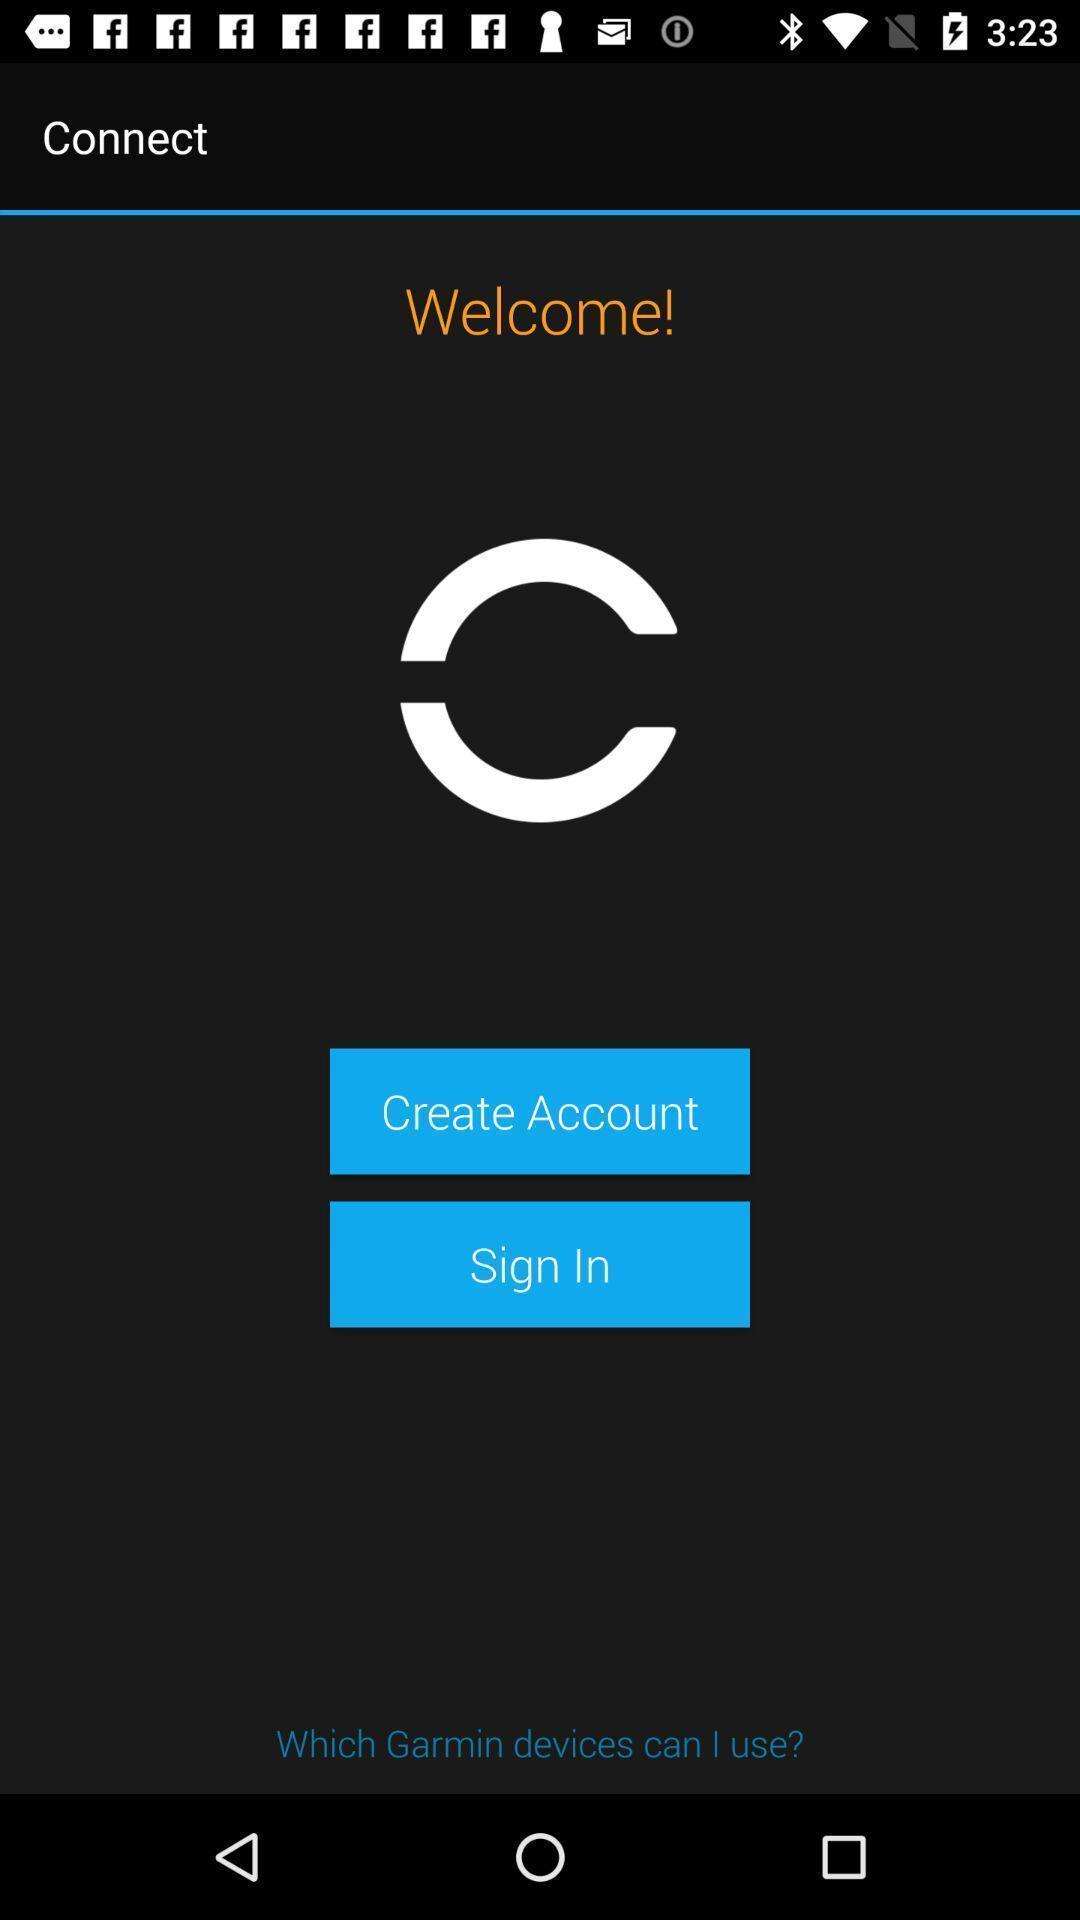Describe the visual elements of this screenshot. Welcome page. 